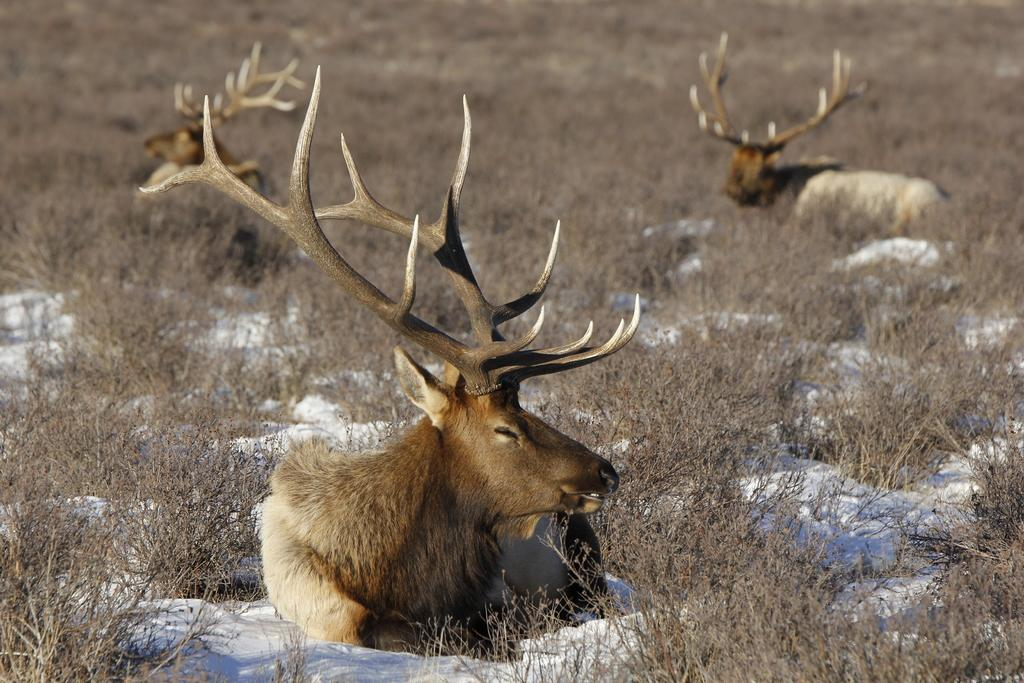How many animals are in the image? There are three animals in the image. What type of animals are they? The animals are elk. What are the elk doing in the image? The elk are sitting. What can be seen on the ground in the image? There is dried grass and snow on the ground. What quarter of the image is the control panel located? There is no control panel present in the image. What activity are the elk participating in the image? The elk are sitting, which is not an activity typically associated with elk. 